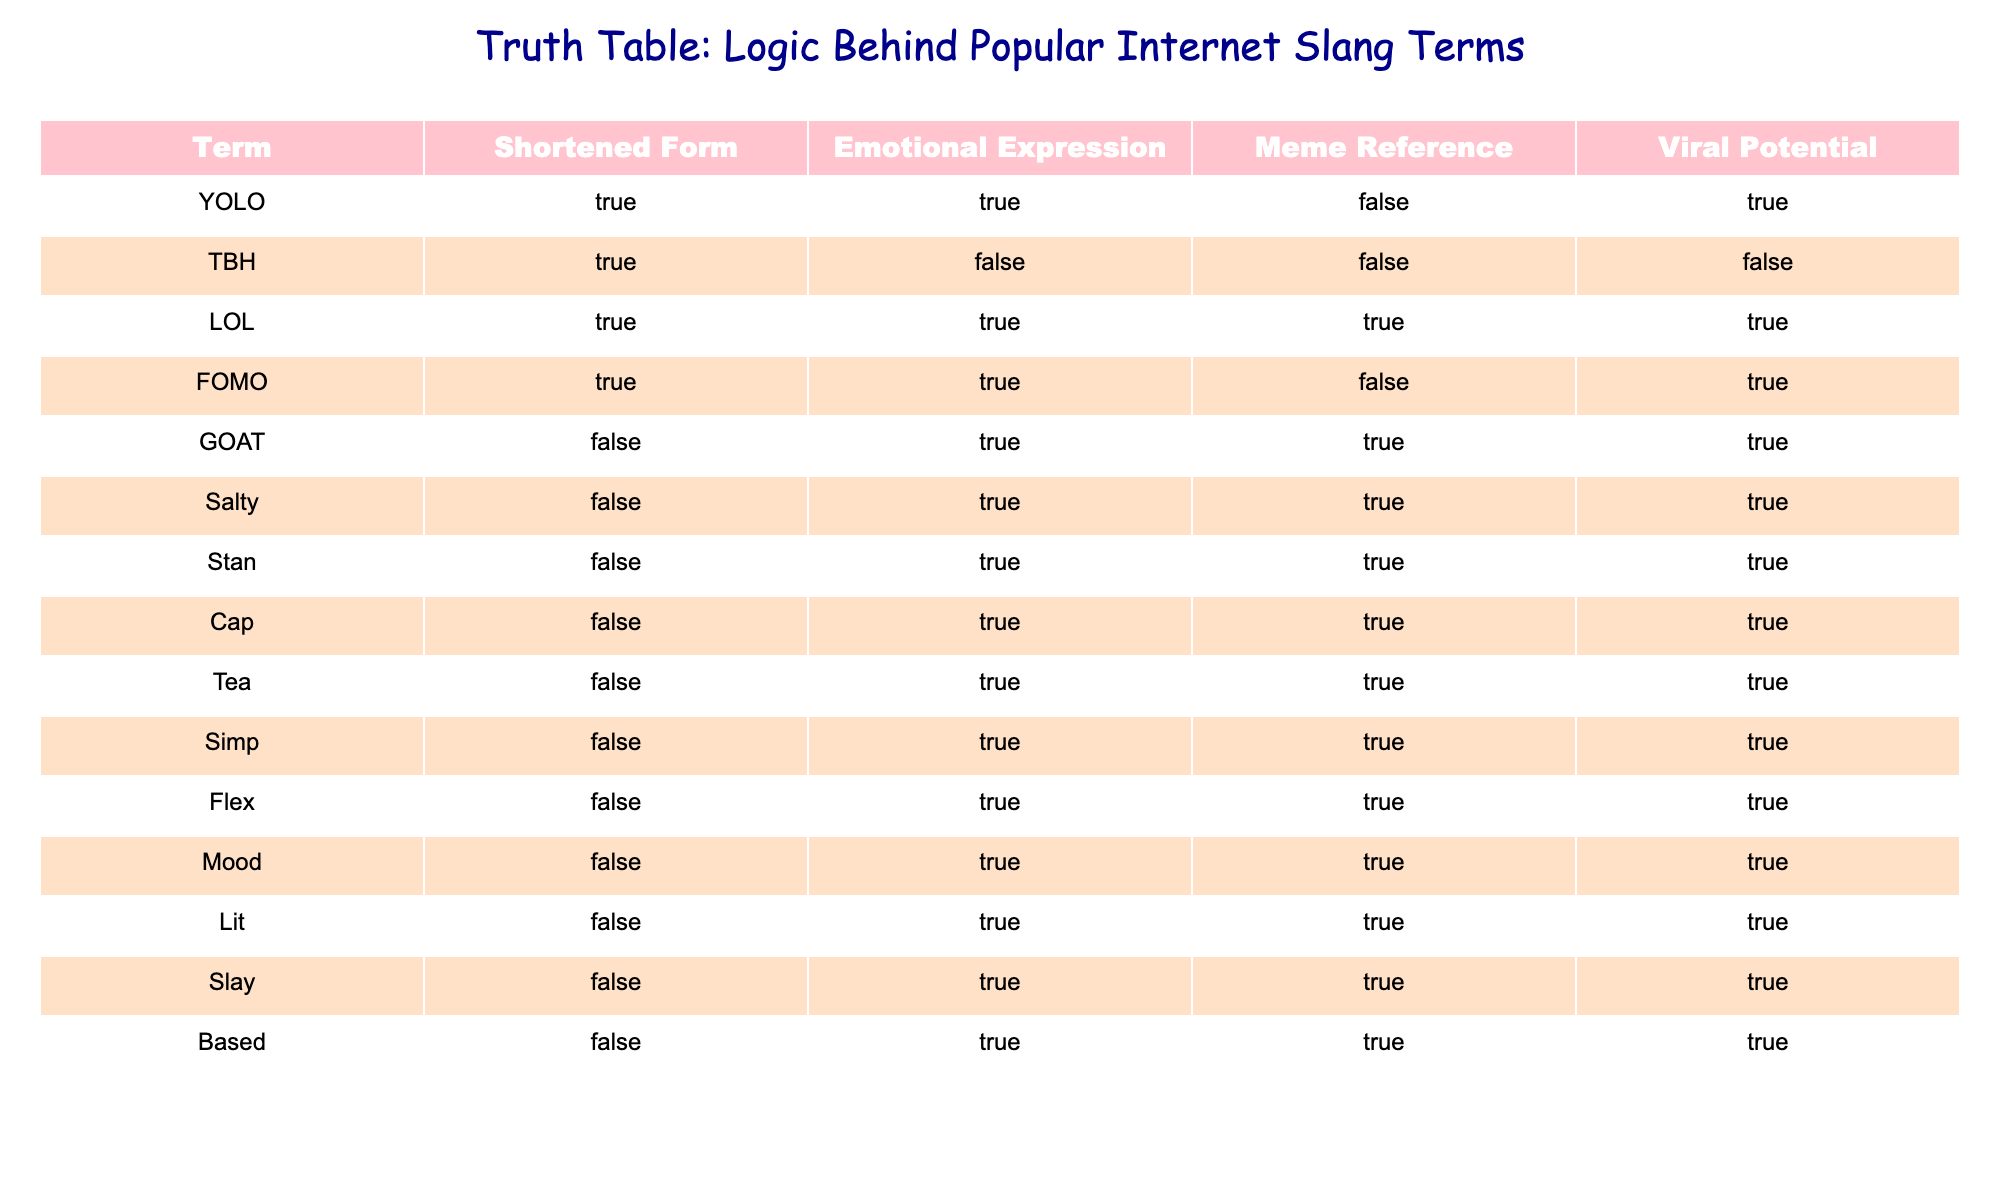What is the emotional expression of the term "FOMO"? According to the table, "FOMO" has an entry under the "Emotional Expression" column marked as True. This indicates that this term conveys an emotional sentiment.
Answer: True How many slang terms are both viral and incorporate an emotional expression? By examining the table, we can see that the terms "YOLO," "LOL," "FOMO," "GOAT," "Salty," "Stan," "Cap," "Tea," "Simp," "Flex," "Mood," "Lit," "Slay," and "Based" each have True values in the "Emotional Expression" column and True values in the "Viral Potential" column. Counting these gives us a total of 13 terms.
Answer: 13 Is the term "Stan" a shortened form? The "Stan" entry in the table shows that its "Shortened Form" is marked as False, indicating that it does not qualify as a shortened form of another term.
Answer: No Which term has the highest viral potential among the listed slang terms? To determine which term has the highest viral potential, we analyze the "Viral Potential" column. The terms "YOLO," "LOL," "FOMO," "GOAT," "Salty," "Stan," "Cap," "Tea," "Simp," "Flex," "Mood," "Lit," "Slay," and "Based" all have True values. Among these, we can categorize "GOAT," "Salty," and "Stan" as also having a strong meme reference. However, "LOL" stands out for also being a meme reference, indicating it's particularly well recognized and used online. Thus, the highest viral potential could be ascribed to "LOL."
Answer: LOL How many slang terms do not have a meme reference? Checking the "Meme Reference" column, if we look for terms marked as False, we find "YOLO," "TBH," and "FOMO." Thus, we count these three terms to arrive at our answer.
Answer: 3 Which slang terms have both an emotional expression and a meme reference? By reviewing both the "Emotional Expression" and "Meme Reference" columns, we see that the terms "LOL," "GOAT," "Salty," "Stan," "Cap," "Tea," "Simp," "Flex," "Mood," "Lit," "Slay," and "Based" have True values in both columns. Upon counting, we find that there are a total of 11 terms that fit this criterion.
Answer: 11 Is "Cap" a term that expresses an emotional sentiment? "Cap" is listed in the "Emotional Expression" column, and the entry shows True, meaning this term does convey an emotional sentiment.
Answer: Yes How many slang terms do not express any emotional sentiment but have a viral potential? In this examination, we look for terms with False in the "Emotional Expression" column and True in the "Viral Potential." Only "TBH" fits this description. Therefore, the total number of terms is 1.
Answer: 1 